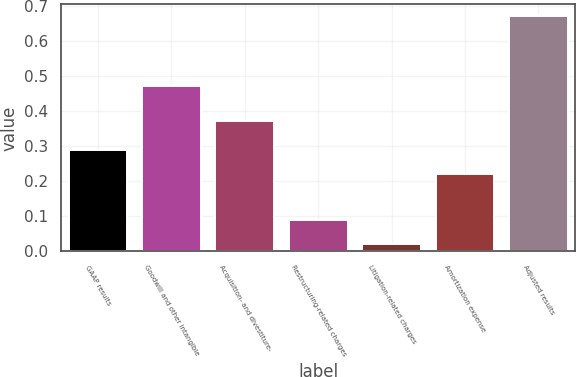<chart> <loc_0><loc_0><loc_500><loc_500><bar_chart><fcel>GAAP results<fcel>Goodwill and other intangible<fcel>Acquisition- and divestiture-<fcel>Restructuring-related charges<fcel>Litigation-related charges<fcel>Amortization expense<fcel>Adjusted results<nl><fcel>0.29<fcel>0.47<fcel>0.37<fcel>0.09<fcel>0.02<fcel>0.22<fcel>0.67<nl></chart> 